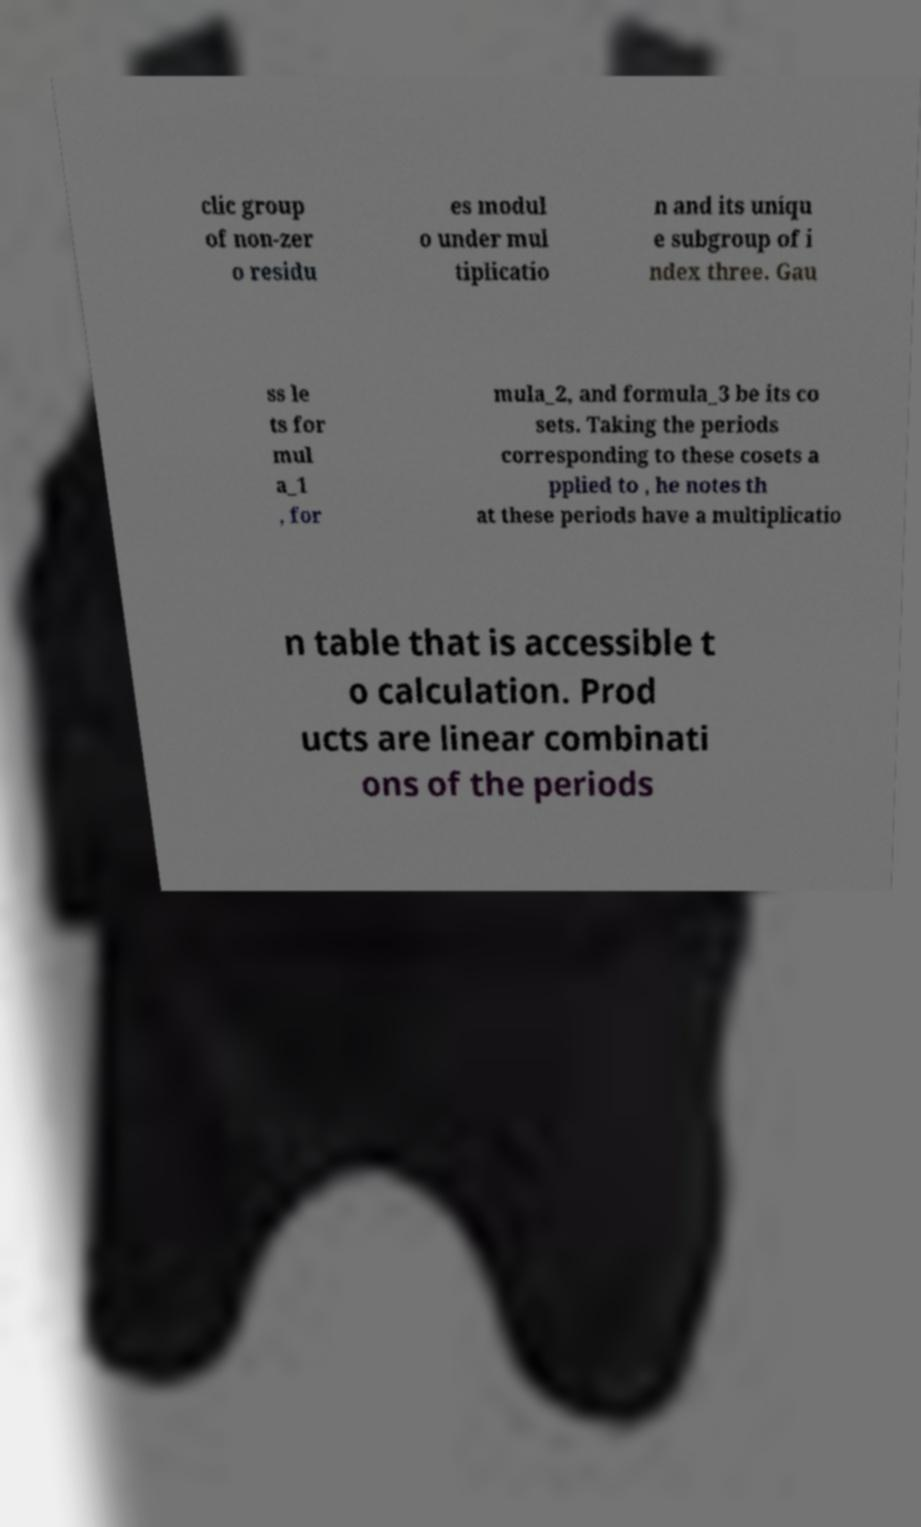Can you read and provide the text displayed in the image?This photo seems to have some interesting text. Can you extract and type it out for me? clic group of non-zer o residu es modul o under mul tiplicatio n and its uniqu e subgroup of i ndex three. Gau ss le ts for mul a_1 , for mula_2, and formula_3 be its co sets. Taking the periods corresponding to these cosets a pplied to , he notes th at these periods have a multiplicatio n table that is accessible t o calculation. Prod ucts are linear combinati ons of the periods 